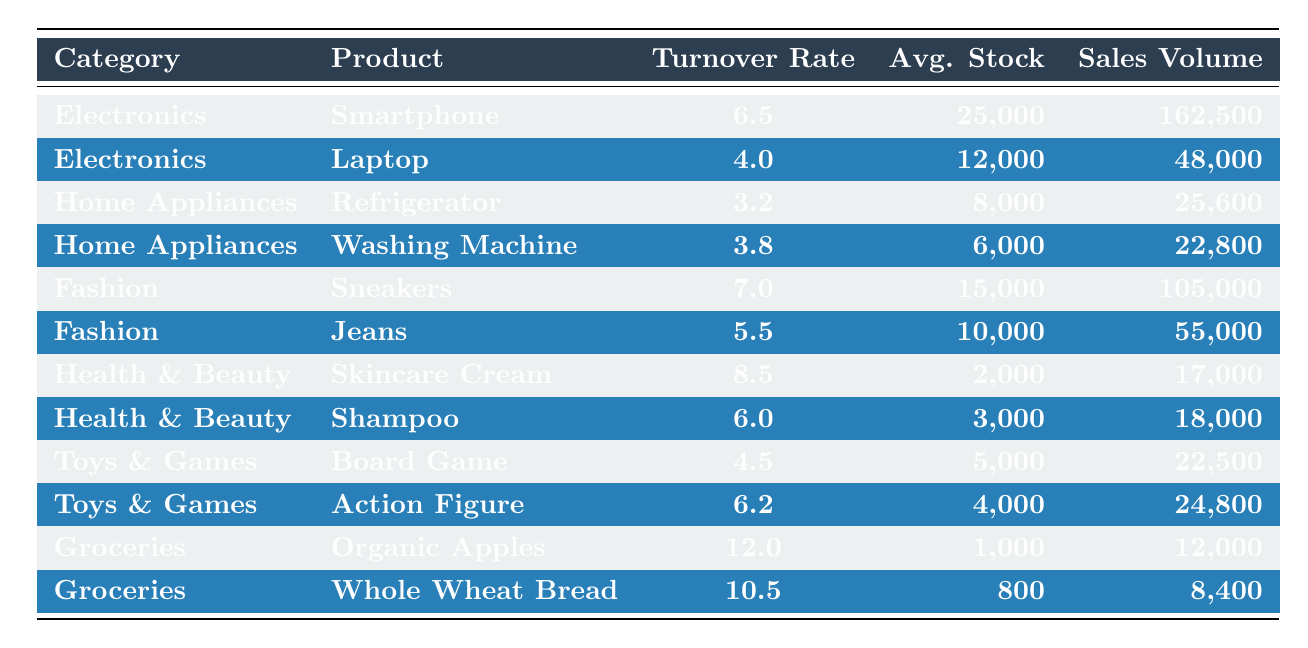What is the inventory turnover rate for Smartphones? To find the answer, lookup the row for "Smartphone" in the "Electronics" category and read the value under the "Turnover Rate" column. The value is 6.5.
Answer: 6.5 Which product has the highest inventory turnover rate? Review the "Turnover Rate" column in the table to identify the maximum value. The highest rate is 12.0 for "Organic Apples."
Answer: Organic Apples What is the average inventory turnover rate for the Home Appliances category? The turnover rates for Home Appliances are 3.2 and 3.8. To find the average, sum these values (3.2 + 3.8 = 7.0) and divide by the number of products (2). Thus, the average is 7.0 / 2 = 3.5.
Answer: 3.5 How many units of "Washing Machines" were sold? Look at the “Sales Volume” for the product “Washing Machine” within the “Home Appliances” category. The value is 22,800.
Answer: 22,800 Is the inventory turnover rate of "Jeans" higher than that of "Laptops"? Compare the turnover rates: "Jeans" has 5.5 and "Laptops" has 4.0. Since 5.5 is greater than 4.0, the statement is true.
Answer: Yes What is the total average stock for all products in the Fashion category? Sum the average stock values for "Sneakers" (15,000) and "Jeans" (10,000), which is 15,000 + 10,000 = 25,000, to find the total average stock.
Answer: 25,000 What is the difference in inventory turnover rate between "Skincare Cream" and "Shampoo"? Subtract the turnover rate of "Shampoo" (6.0) from that of "Skincare Cream" (8.5). The difference is 8.5 - 6.0 = 2.5.
Answer: 2.5 Which product category has the lowest average turnover rate? Calculate the average turnover rates for each category. For "Home Appliances," it is (3.2 + 3.8) / 2 = 3.5; for "Fashion," (7.0 + 5.5) / 2 = 6.25; for "Health & Beauty," (8.5 + 6.0) / 2 = 7.25; for "Toys & Games," (4.5 + 6.2) / 2 = 5.35; and for "Groceries," (12.0 + 10.5) / 2 = 11.25. The lowest is 3.5 for "Home Appliances."
Answer: Home Appliances What is the total sales volume for all products in the Groceries category? Sum the sales volumes of "Organic Apples" (12,000) and "Whole Wheat Bread" (8,400): 12,000 + 8,400 = 20,400.
Answer: 20,400 Is it true that all products in the Health & Beauty category have an inventory turnover rate greater than 5? Check the turnover rates for both products: "Skincare Cream" has 8.5 and "Shampoo" has 6.0, which are both greater than 5, confirming the statement is true.
Answer: Yes 